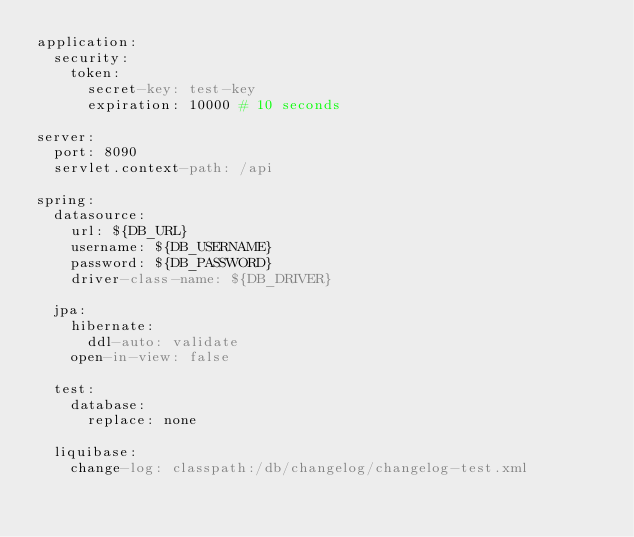Convert code to text. <code><loc_0><loc_0><loc_500><loc_500><_YAML_>application:
  security:
    token:
      secret-key: test-key
      expiration: 10000 # 10 seconds

server:
  port: 8090
  servlet.context-path: /api

spring:
  datasource:
    url: ${DB_URL}
    username: ${DB_USERNAME}
    password: ${DB_PASSWORD}
    driver-class-name: ${DB_DRIVER}

  jpa:
    hibernate:
      ddl-auto: validate
    open-in-view: false

  test:
    database:
      replace: none

  liquibase:
    change-log: classpath:/db/changelog/changelog-test.xml
</code> 